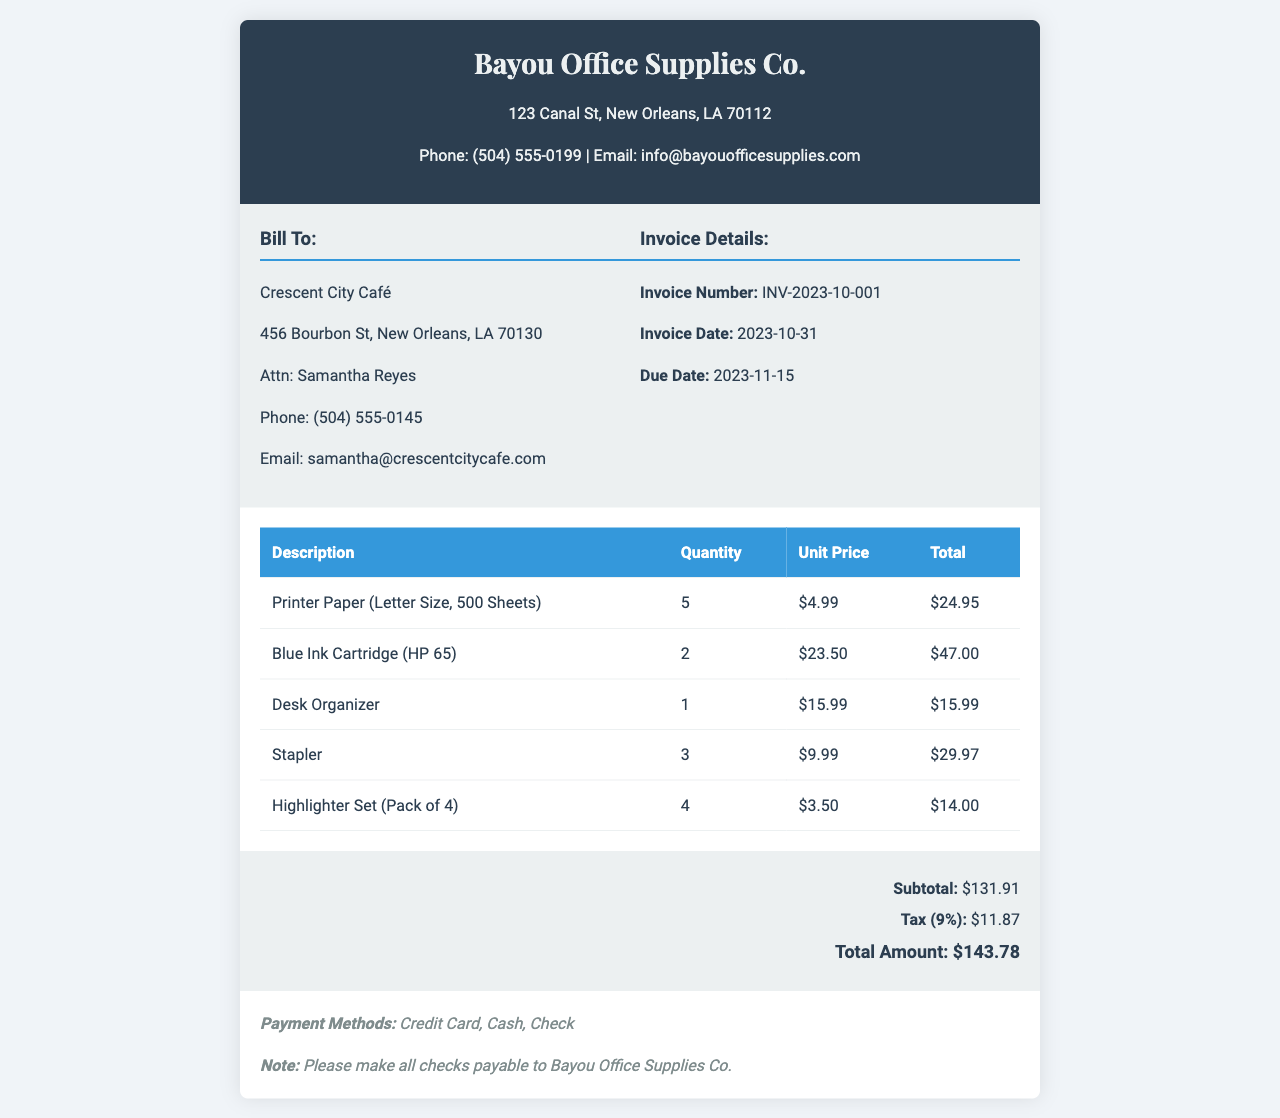What is the invoice number? The invoice number is clearly stated in the invoice details section, which is INV-2023-10-001.
Answer: INV-2023-10-001 What is the total amount due? The total amount is calculated at the bottom of the invoice summary, which is $143.78.
Answer: $143.78 What is the due date for payment? The due date is mentioned in the invoice details section, which is 2023-11-15.
Answer: 2023-11-15 How many units of Printer Paper were purchased? The quantity of Printer Paper is listed in the items table, which is 5.
Answer: 5 What is the subtotal before tax? The subtotal is provided in the invoice summary section, which is $131.91.
Answer: $131.91 What does the invoice note suggest for payment? The note specifies that checks should be made payable to Bayou Office Supplies Co., indicating payment methods.
Answer: Bayou Office Supplies Co What percentage is the tax applied? The tax percentage is mentioned in the invoice summary, which states 9%.
Answer: 9% Who is the bill recipient? The recipient's name is indicated at the top of the bill-to section, which is Crescent City Café.
Answer: Crescent City Café What is the price of the Blue Ink Cartridge? The price of the Blue Ink Cartridge is listed in the invoice items table as $23.50.
Answer: $23.50 